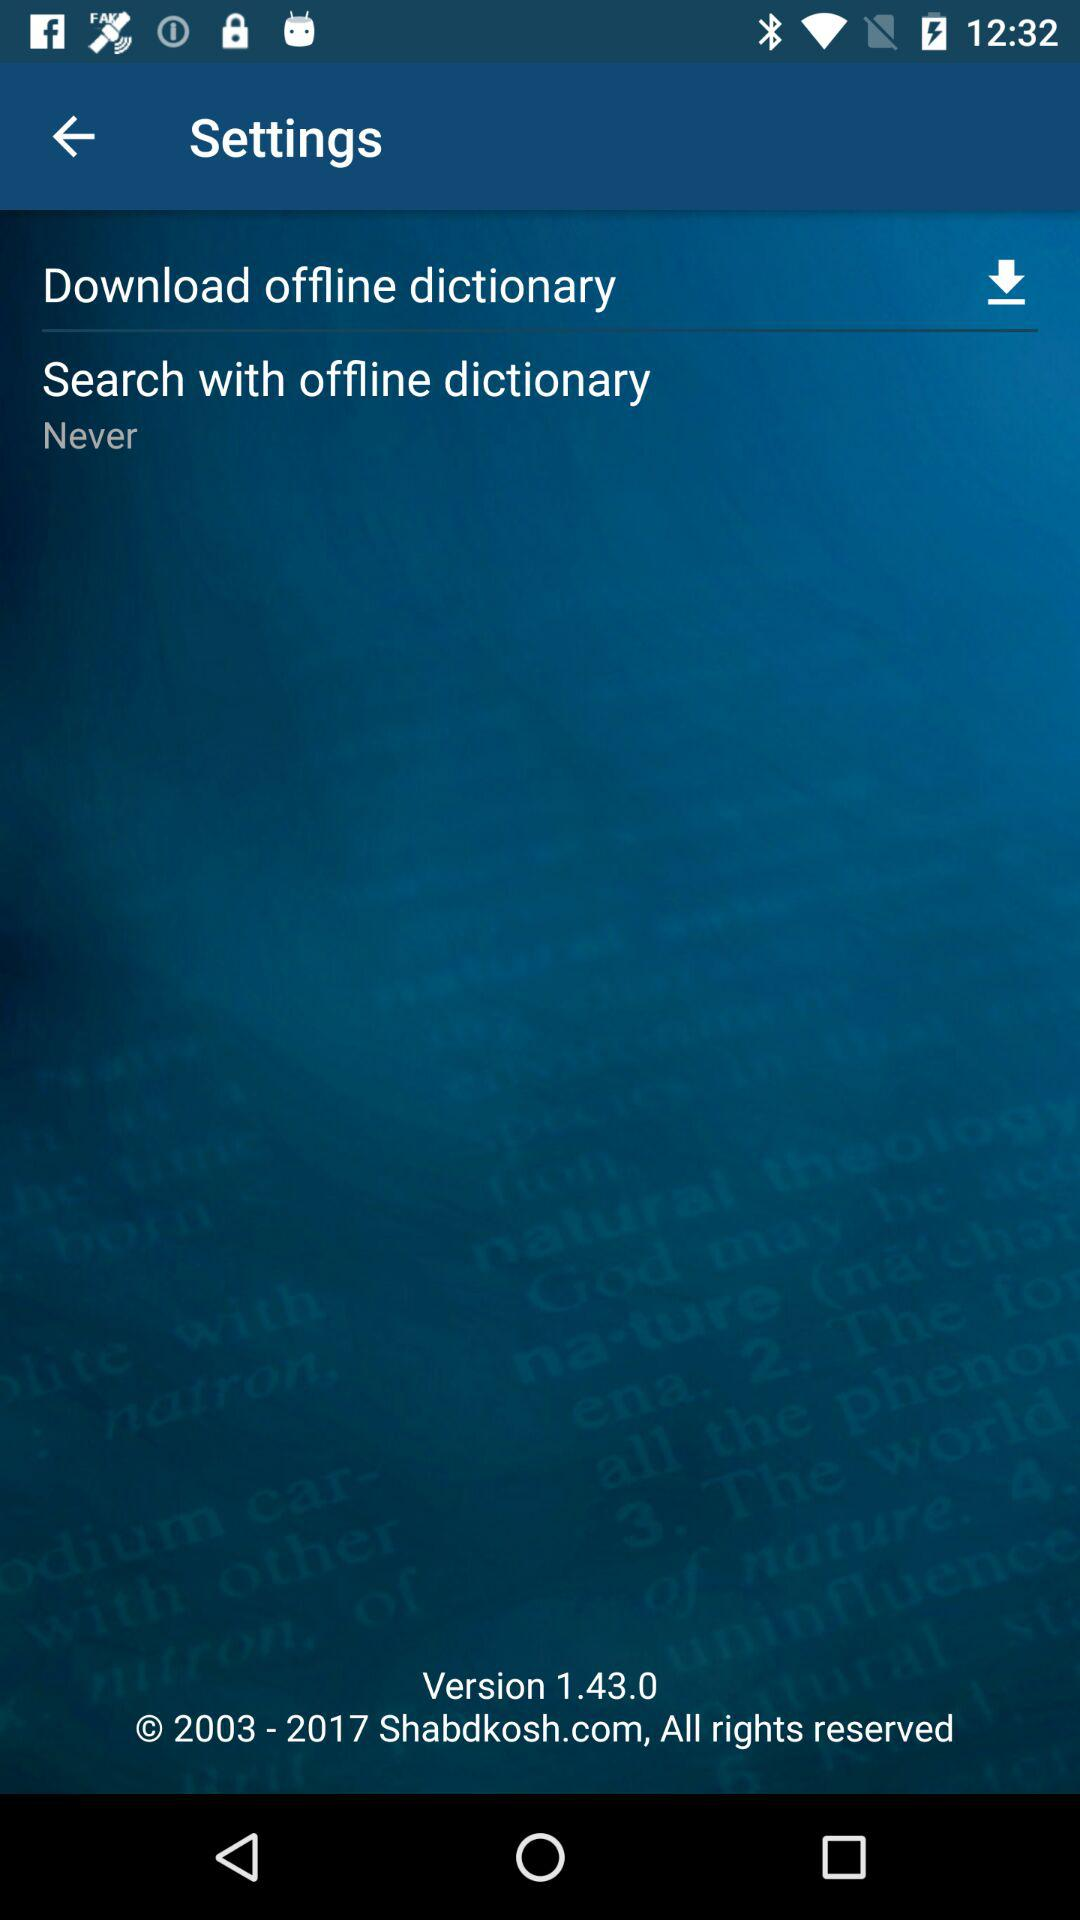What is the website? The website is Shabdkosh.com. 